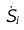<formula> <loc_0><loc_0><loc_500><loc_500>\dot { S } _ { i }</formula> 